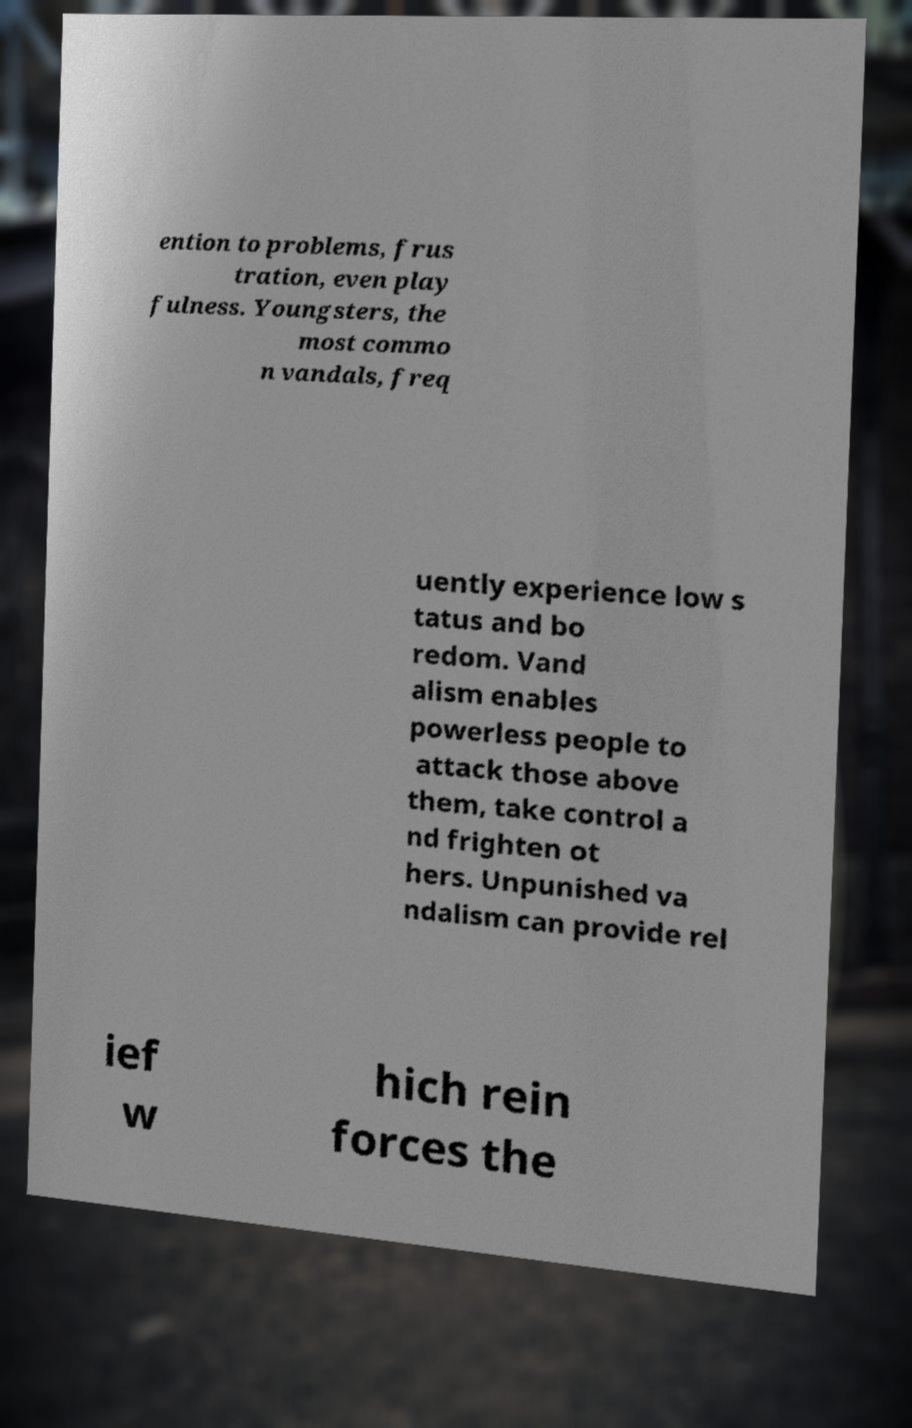For documentation purposes, I need the text within this image transcribed. Could you provide that? ention to problems, frus tration, even play fulness. Youngsters, the most commo n vandals, freq uently experience low s tatus and bo redom. Vand alism enables powerless people to attack those above them, take control a nd frighten ot hers. Unpunished va ndalism can provide rel ief w hich rein forces the 